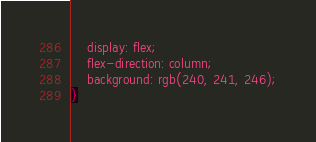Convert code to text. <code><loc_0><loc_0><loc_500><loc_500><_CSS_>    display: flex;
    flex-direction: column;
    background: rgb(240, 241, 246);
}</code> 